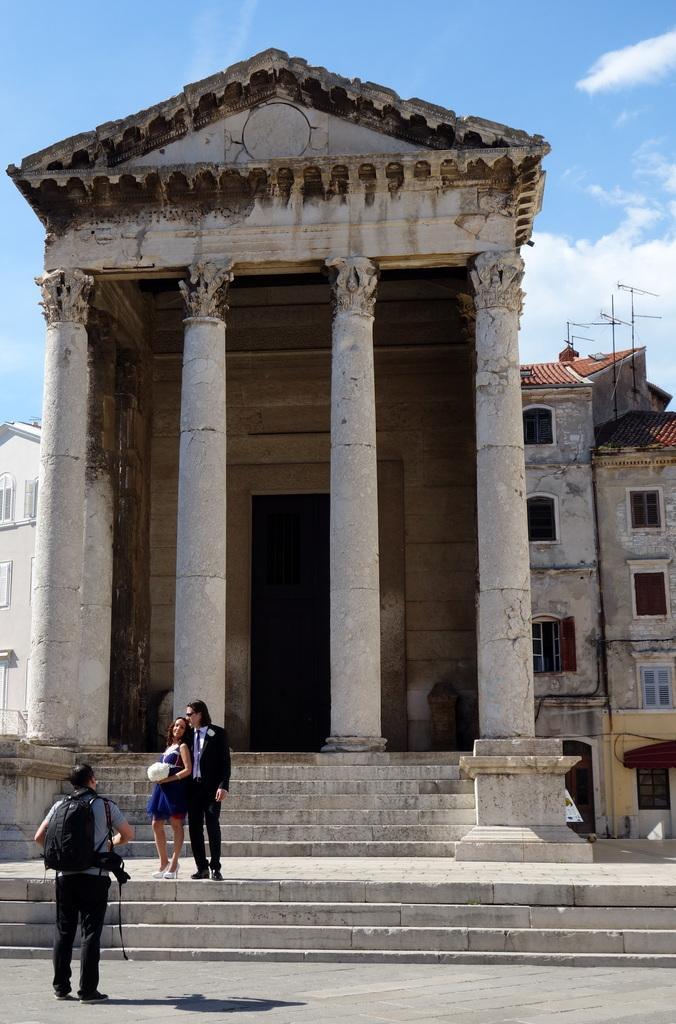Could you give a brief overview of what you see in this image? In this image in front there is a person standing on the road. In front of him there are two persons standing on the stairs. In the background of the image there are buildings and sky. 